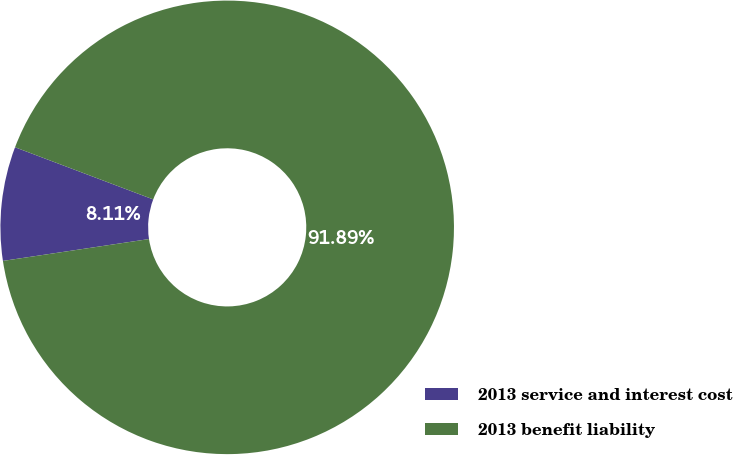Convert chart. <chart><loc_0><loc_0><loc_500><loc_500><pie_chart><fcel>2013 service and interest cost<fcel>2013 benefit liability<nl><fcel>8.11%<fcel>91.89%<nl></chart> 